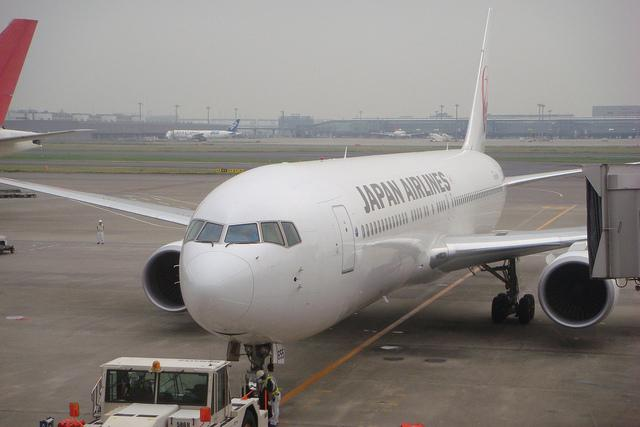What is the official language of this airline's country? japanese 